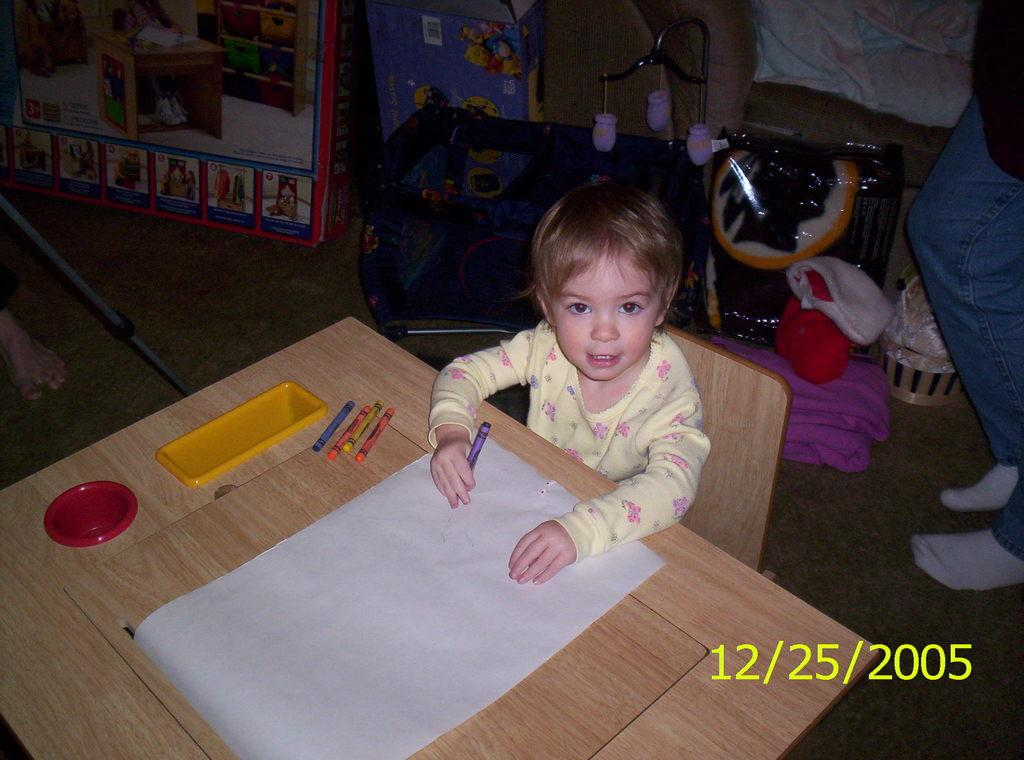What is the main subject of the image? There is a kid in the image. What is the kid doing in the image? The kid is sitting on a chair. What objects are on the table in the image? There is a paper, pencils, and a box on the table. What can be seen on the floor in the image? The floor is visible in the image. What type of pear is the scarecrow holding in the image? There is no scarecrow or pear present in the image. How many wheels can be seen on the chair the kid is sitting on? The chair the kid is sitting on does not have any visible wheels. 